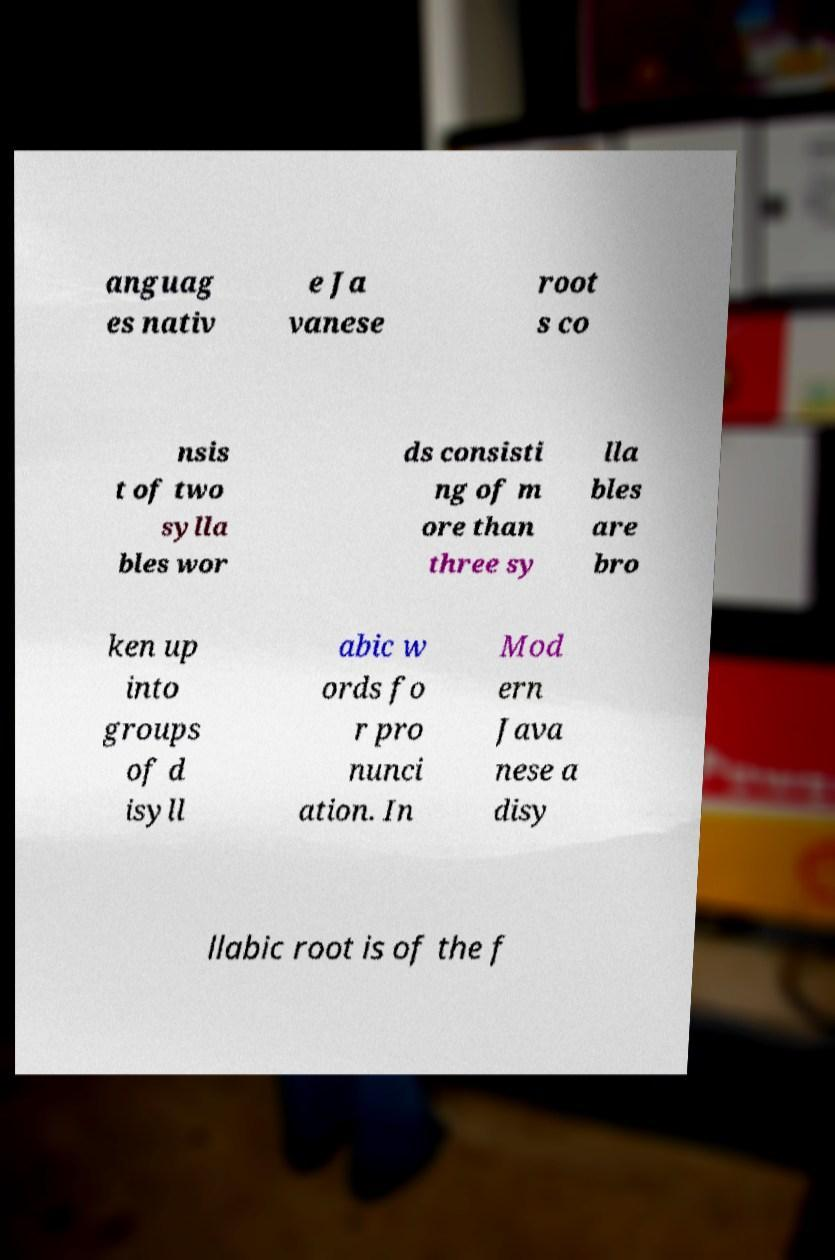What messages or text are displayed in this image? I need them in a readable, typed format. anguag es nativ e Ja vanese root s co nsis t of two sylla bles wor ds consisti ng of m ore than three sy lla bles are bro ken up into groups of d isyll abic w ords fo r pro nunci ation. In Mod ern Java nese a disy llabic root is of the f 